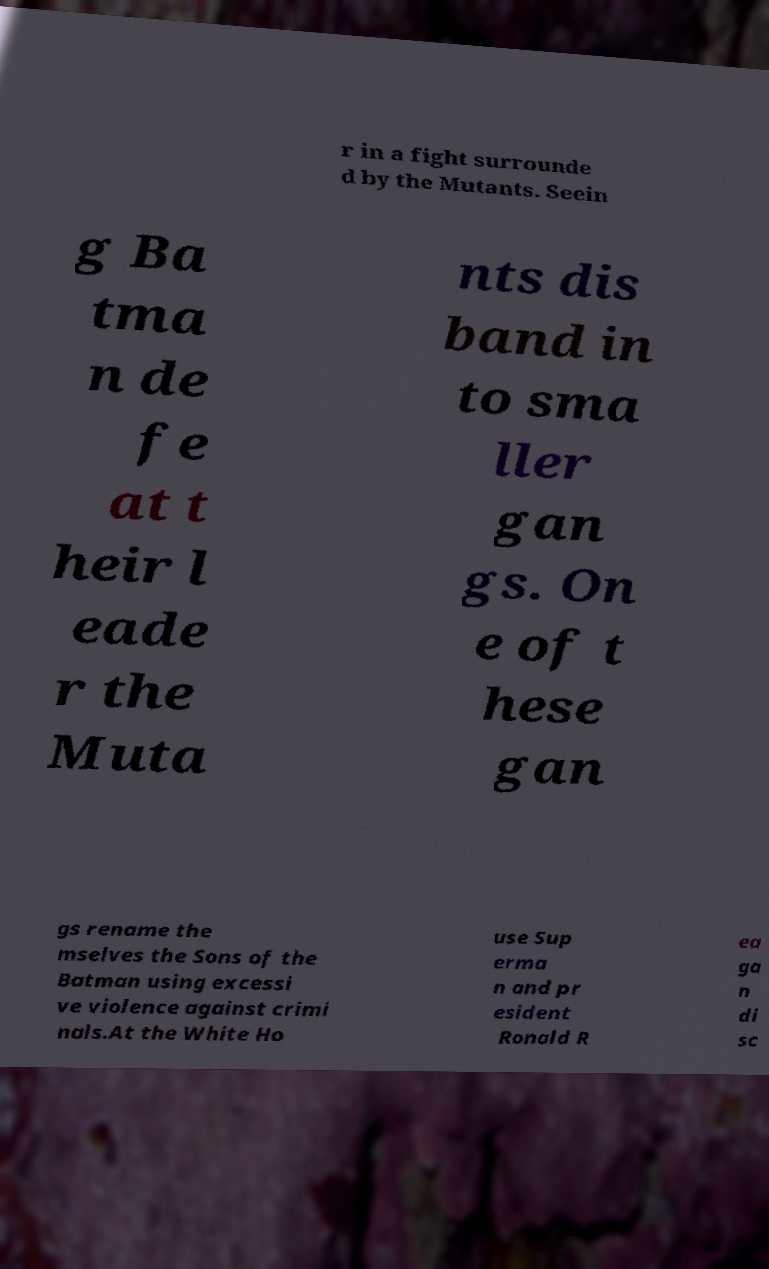What messages or text are displayed in this image? I need them in a readable, typed format. r in a fight surrounde d by the Mutants. Seein g Ba tma n de fe at t heir l eade r the Muta nts dis band in to sma ller gan gs. On e of t hese gan gs rename the mselves the Sons of the Batman using excessi ve violence against crimi nals.At the White Ho use Sup erma n and pr esident Ronald R ea ga n di sc 